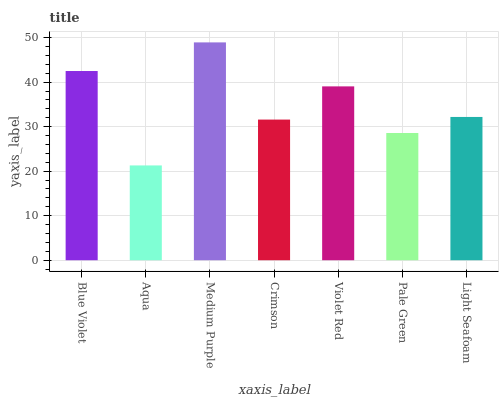Is Aqua the minimum?
Answer yes or no. Yes. Is Medium Purple the maximum?
Answer yes or no. Yes. Is Medium Purple the minimum?
Answer yes or no. No. Is Aqua the maximum?
Answer yes or no. No. Is Medium Purple greater than Aqua?
Answer yes or no. Yes. Is Aqua less than Medium Purple?
Answer yes or no. Yes. Is Aqua greater than Medium Purple?
Answer yes or no. No. Is Medium Purple less than Aqua?
Answer yes or no. No. Is Light Seafoam the high median?
Answer yes or no. Yes. Is Light Seafoam the low median?
Answer yes or no. Yes. Is Blue Violet the high median?
Answer yes or no. No. Is Crimson the low median?
Answer yes or no. No. 